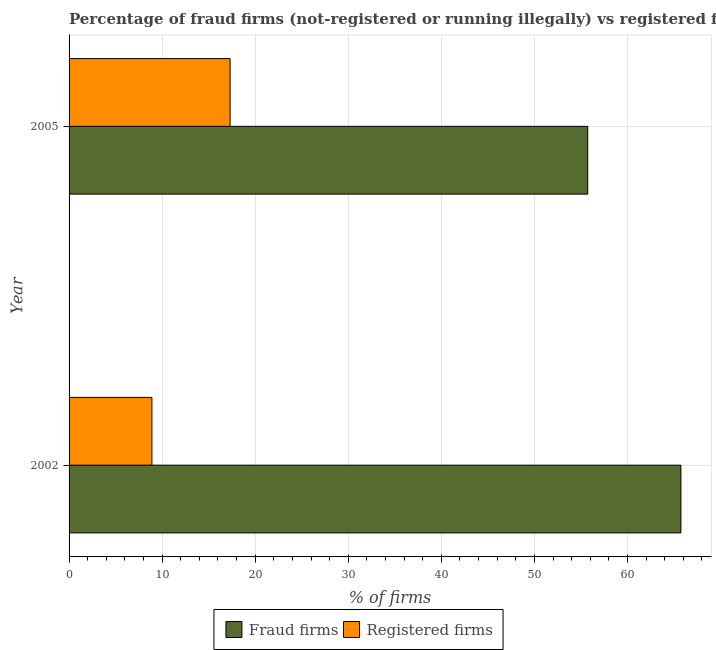How many groups of bars are there?
Keep it short and to the point. 2. Are the number of bars per tick equal to the number of legend labels?
Your answer should be very brief. Yes. What is the percentage of registered firms in 2005?
Give a very brief answer. 17.3. Across all years, what is the maximum percentage of fraud firms?
Give a very brief answer. 65.74. Across all years, what is the minimum percentage of fraud firms?
Make the answer very short. 55.73. In which year was the percentage of registered firms maximum?
Provide a succinct answer. 2005. What is the total percentage of registered firms in the graph?
Your response must be concise. 26.2. What is the difference between the percentage of fraud firms in 2002 and that in 2005?
Your answer should be compact. 10.01. What is the difference between the percentage of registered firms in 2002 and the percentage of fraud firms in 2005?
Offer a very short reply. -46.83. In the year 2005, what is the difference between the percentage of registered firms and percentage of fraud firms?
Offer a very short reply. -38.43. In how many years, is the percentage of registered firms greater than 66 %?
Your answer should be compact. 0. What is the ratio of the percentage of registered firms in 2002 to that in 2005?
Offer a terse response. 0.51. Is the percentage of registered firms in 2002 less than that in 2005?
Provide a short and direct response. Yes. In how many years, is the percentage of registered firms greater than the average percentage of registered firms taken over all years?
Provide a succinct answer. 1. What does the 2nd bar from the top in 2005 represents?
Ensure brevity in your answer.  Fraud firms. What does the 1st bar from the bottom in 2005 represents?
Keep it short and to the point. Fraud firms. How many bars are there?
Your answer should be compact. 4. How many years are there in the graph?
Ensure brevity in your answer.  2. Does the graph contain any zero values?
Your answer should be compact. No. What is the title of the graph?
Ensure brevity in your answer.  Percentage of fraud firms (not-registered or running illegally) vs registered firms in Macedonia. Does "Working capital" appear as one of the legend labels in the graph?
Your answer should be very brief. No. What is the label or title of the X-axis?
Provide a succinct answer. % of firms. What is the label or title of the Y-axis?
Ensure brevity in your answer.  Year. What is the % of firms in Fraud firms in 2002?
Offer a very short reply. 65.74. What is the % of firms in Fraud firms in 2005?
Your answer should be very brief. 55.73. Across all years, what is the maximum % of firms of Fraud firms?
Your answer should be very brief. 65.74. Across all years, what is the minimum % of firms of Fraud firms?
Offer a very short reply. 55.73. Across all years, what is the minimum % of firms in Registered firms?
Offer a terse response. 8.9. What is the total % of firms in Fraud firms in the graph?
Offer a very short reply. 121.47. What is the total % of firms in Registered firms in the graph?
Provide a short and direct response. 26.2. What is the difference between the % of firms in Fraud firms in 2002 and that in 2005?
Give a very brief answer. 10.01. What is the difference between the % of firms in Registered firms in 2002 and that in 2005?
Make the answer very short. -8.4. What is the difference between the % of firms in Fraud firms in 2002 and the % of firms in Registered firms in 2005?
Your answer should be very brief. 48.44. What is the average % of firms in Fraud firms per year?
Offer a terse response. 60.73. What is the average % of firms of Registered firms per year?
Your answer should be very brief. 13.1. In the year 2002, what is the difference between the % of firms in Fraud firms and % of firms in Registered firms?
Keep it short and to the point. 56.84. In the year 2005, what is the difference between the % of firms in Fraud firms and % of firms in Registered firms?
Offer a terse response. 38.43. What is the ratio of the % of firms in Fraud firms in 2002 to that in 2005?
Make the answer very short. 1.18. What is the ratio of the % of firms of Registered firms in 2002 to that in 2005?
Your response must be concise. 0.51. What is the difference between the highest and the second highest % of firms in Fraud firms?
Your response must be concise. 10.01. What is the difference between the highest and the second highest % of firms in Registered firms?
Your answer should be very brief. 8.4. What is the difference between the highest and the lowest % of firms of Fraud firms?
Keep it short and to the point. 10.01. What is the difference between the highest and the lowest % of firms in Registered firms?
Your answer should be very brief. 8.4. 